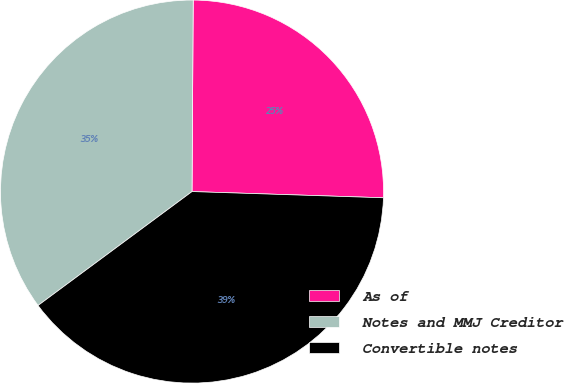<chart> <loc_0><loc_0><loc_500><loc_500><pie_chart><fcel>As of<fcel>Notes and MMJ Creditor<fcel>Convertible notes<nl><fcel>25.42%<fcel>35.24%<fcel>39.35%<nl></chart> 